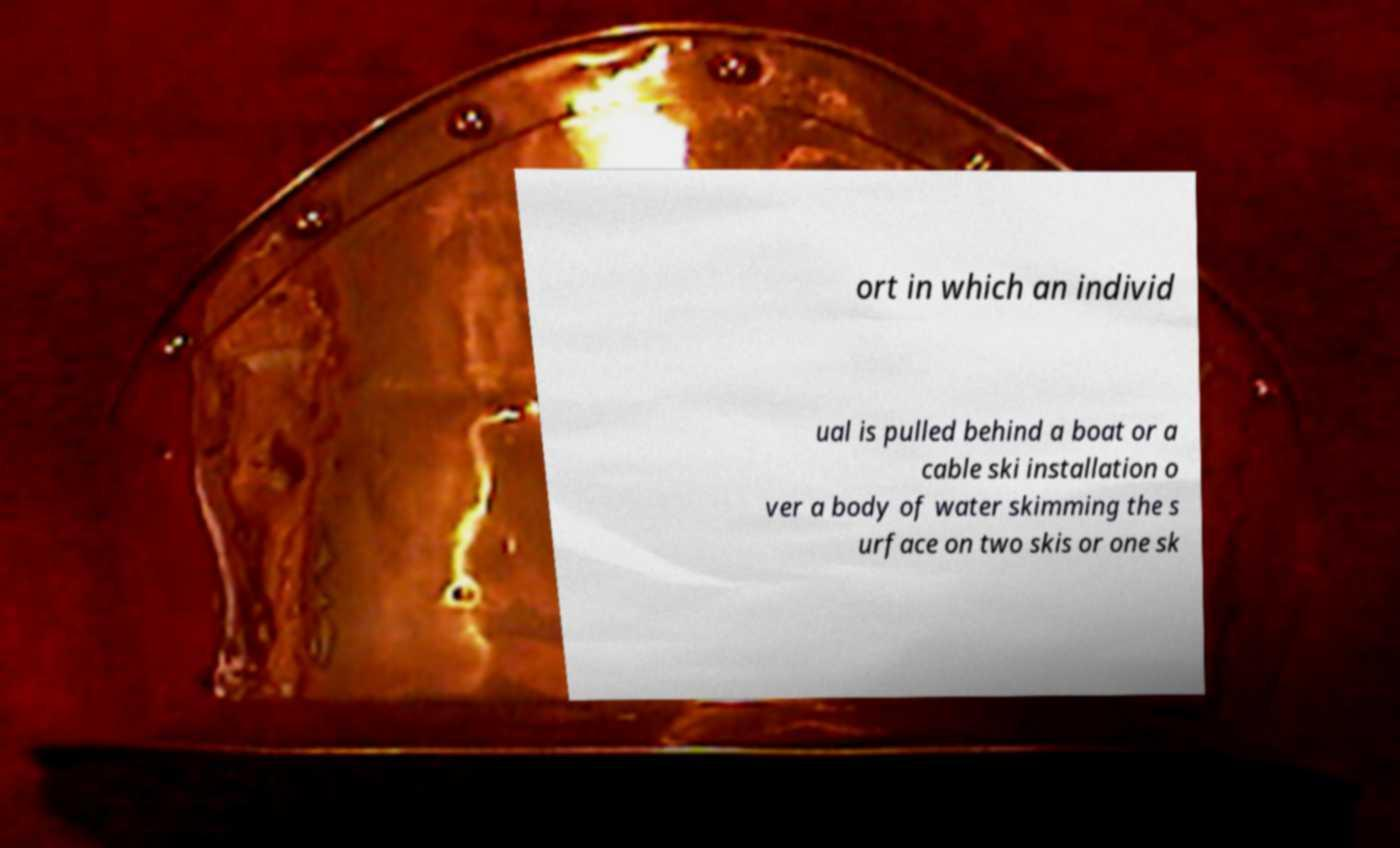Could you extract and type out the text from this image? ort in which an individ ual is pulled behind a boat or a cable ski installation o ver a body of water skimming the s urface on two skis or one sk 